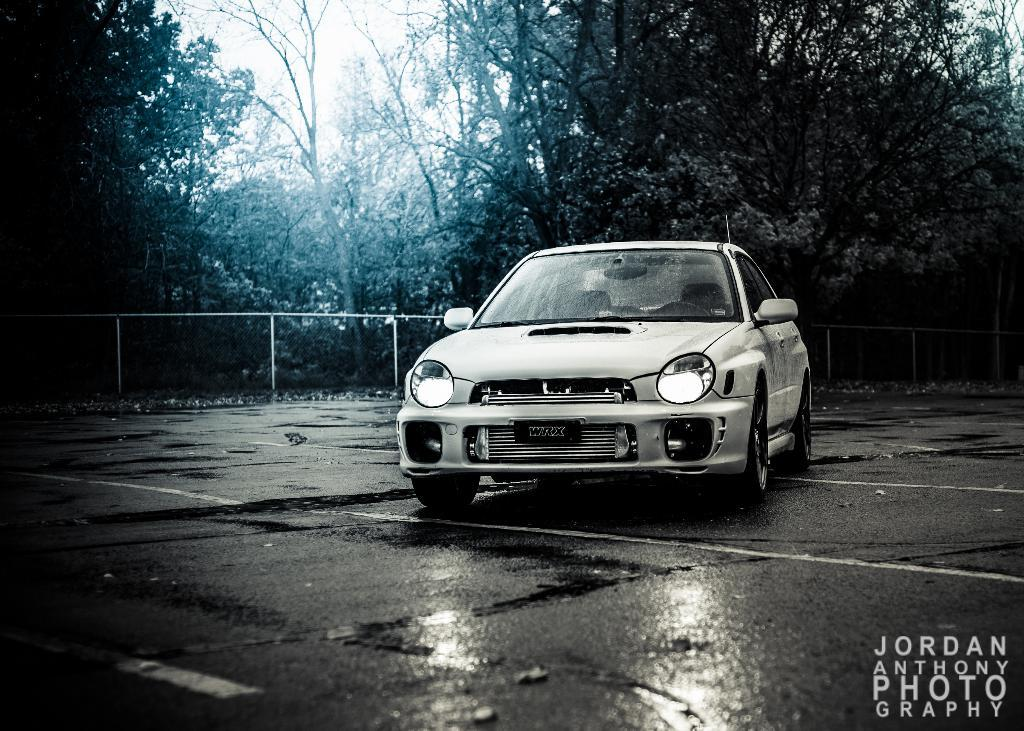What is the main subject of the image? There is a car on the road in the image. What can be seen in the background of the image? In the background of the image, there is a fence, plants, trees, and the sky. Is there any text present in the image? Yes, there is text written at the bottom of the image. What time of day does the argument take place in the image? There is no argument present in the image, so it is not possible to determine the time of day. 